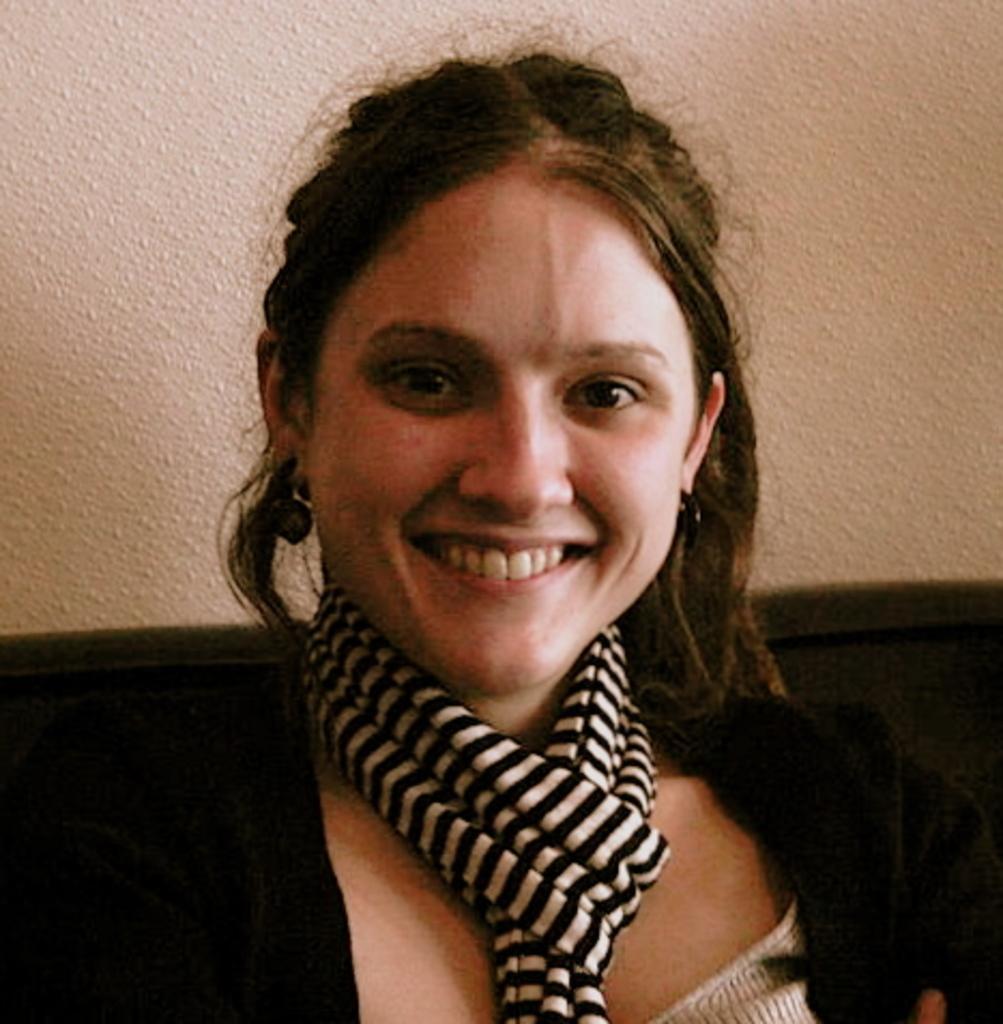Could you give a brief overview of what you see in this image? In this image there is a woman with smile on her face, behind her there is a wall. 